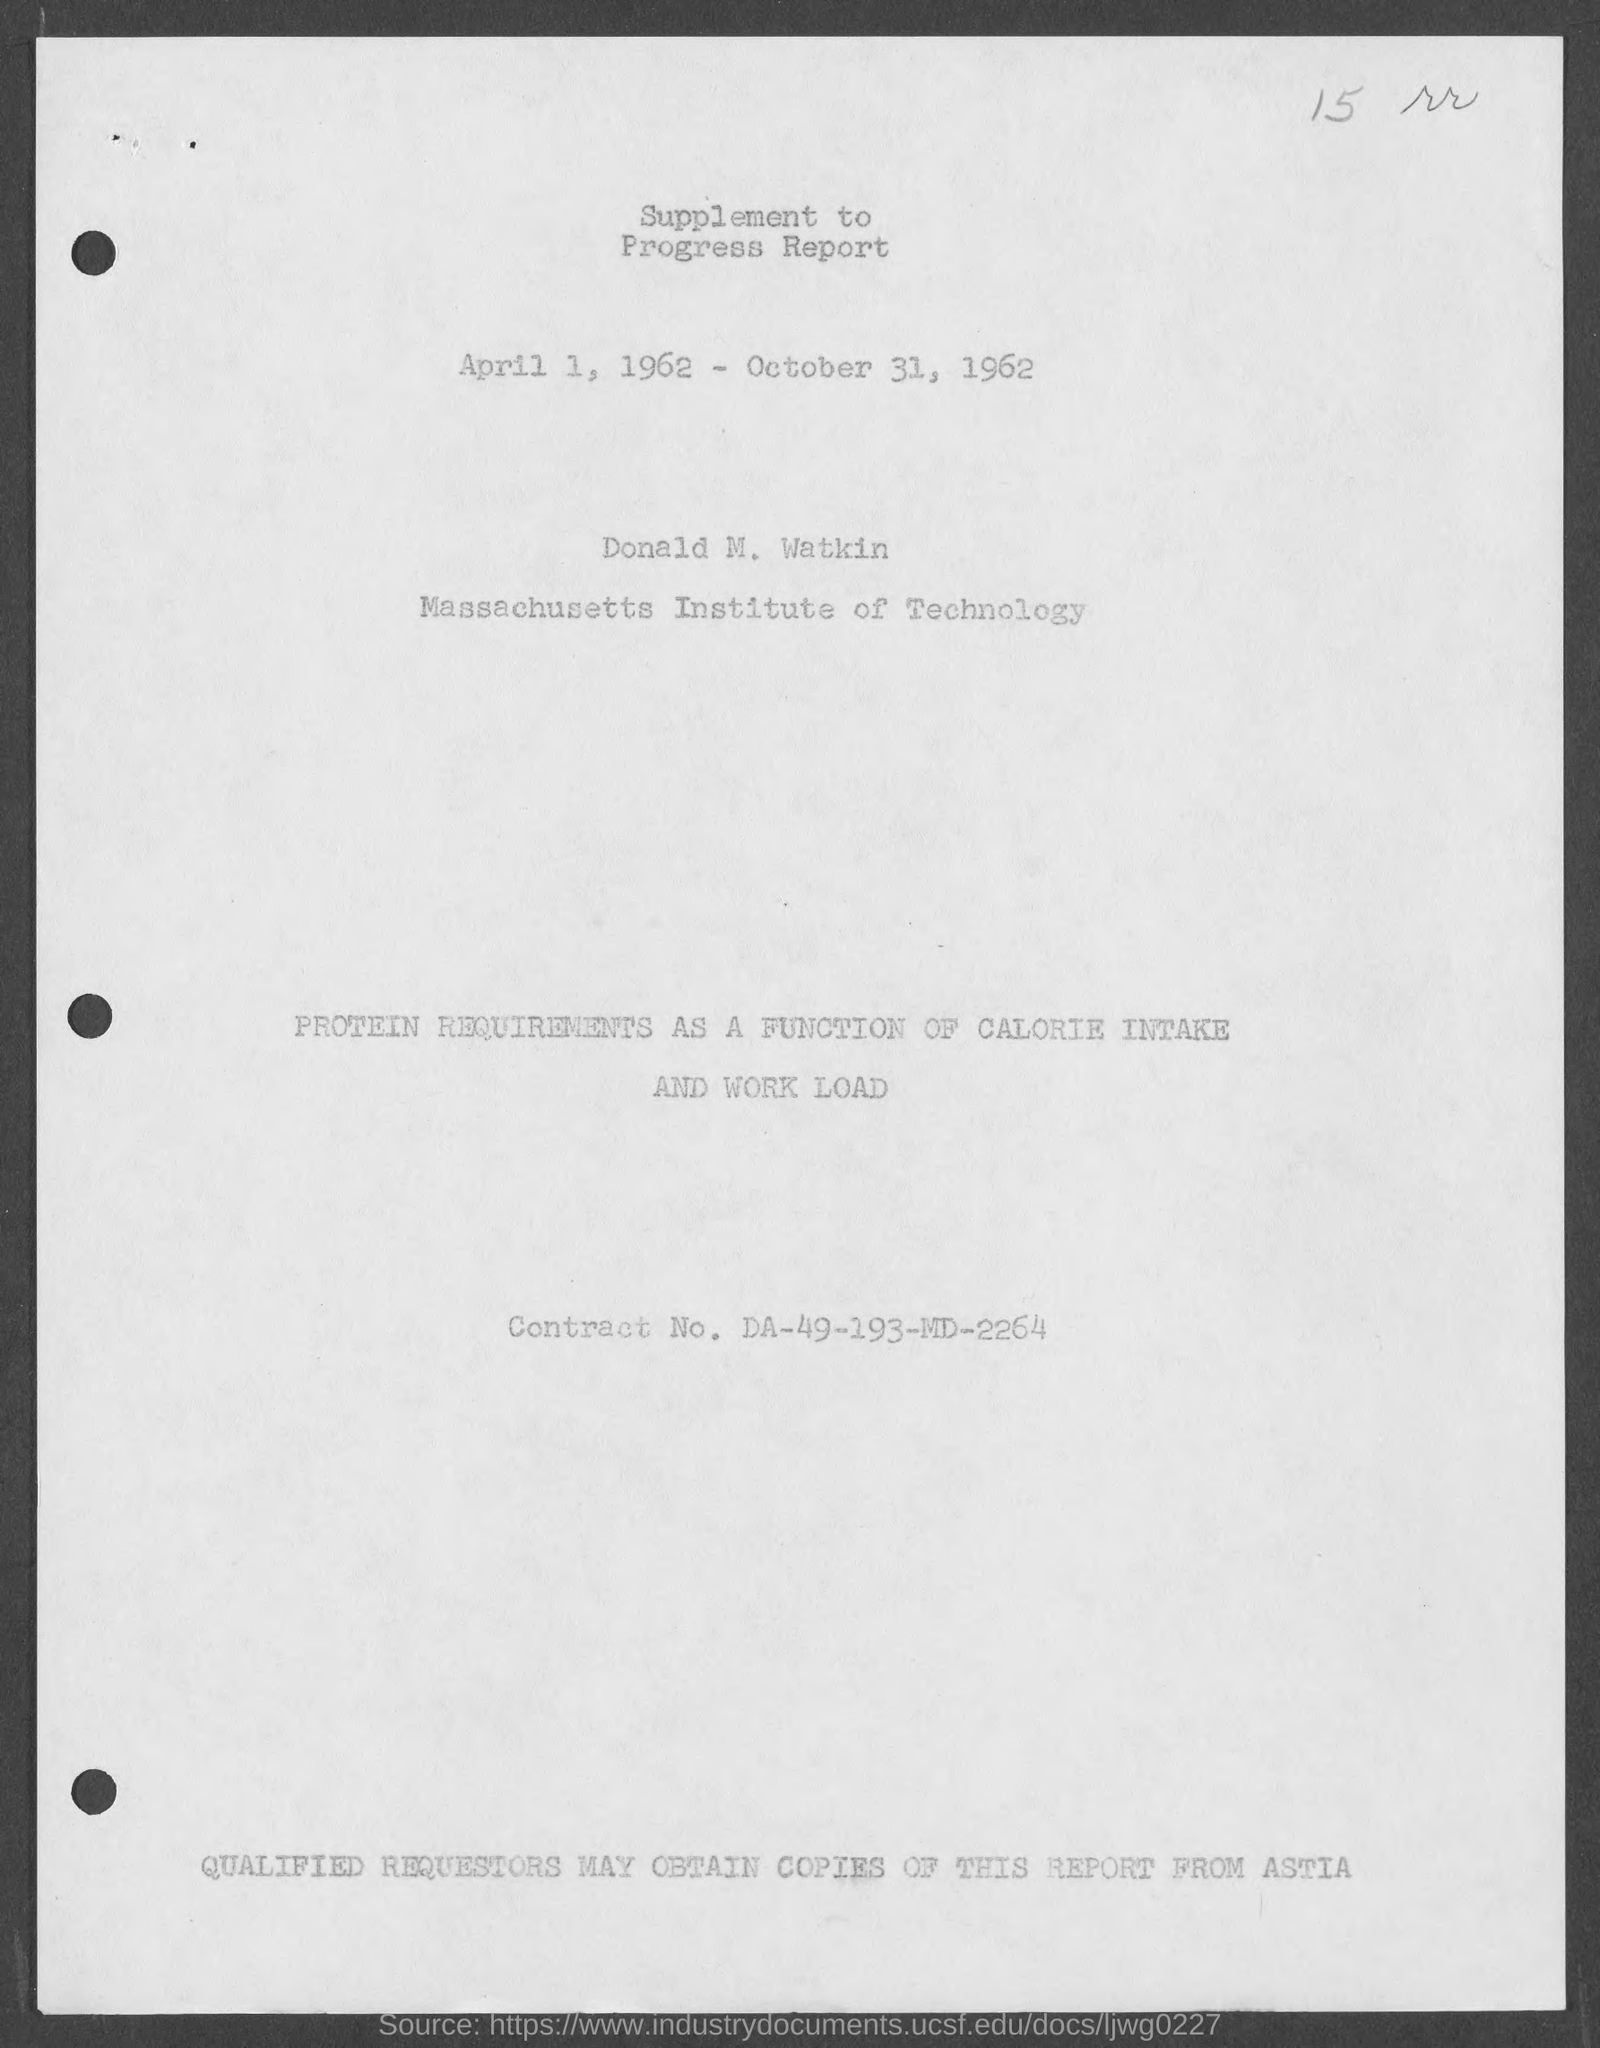What is the Contract No. given in the document?
Your response must be concise. DA-49-193-MD-2264. What is the date mentioned in this document?
Give a very brief answer. April 1, 1962 - October 31, 1962. 